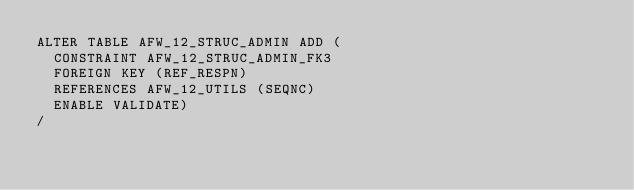Convert code to text. <code><loc_0><loc_0><loc_500><loc_500><_SQL_>ALTER TABLE AFW_12_STRUC_ADMIN ADD (
  CONSTRAINT AFW_12_STRUC_ADMIN_FK3 
  FOREIGN KEY (REF_RESPN) 
  REFERENCES AFW_12_UTILS (SEQNC)
  ENABLE VALIDATE)
/
</code> 